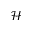<formula> <loc_0><loc_0><loc_500><loc_500>\mathcal { H }</formula> 